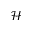<formula> <loc_0><loc_0><loc_500><loc_500>\mathcal { H }</formula> 